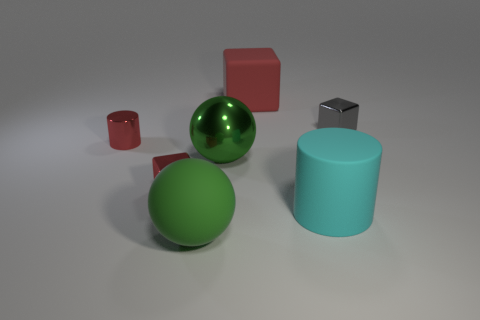Subtract all green spheres. How many were subtracted if there are1green spheres left? 1 Add 1 small objects. How many objects exist? 8 Subtract all balls. How many objects are left? 5 Add 4 rubber things. How many rubber things are left? 7 Add 3 red matte objects. How many red matte objects exist? 4 Subtract 1 green spheres. How many objects are left? 6 Subtract all small green metallic objects. Subtract all matte cylinders. How many objects are left? 6 